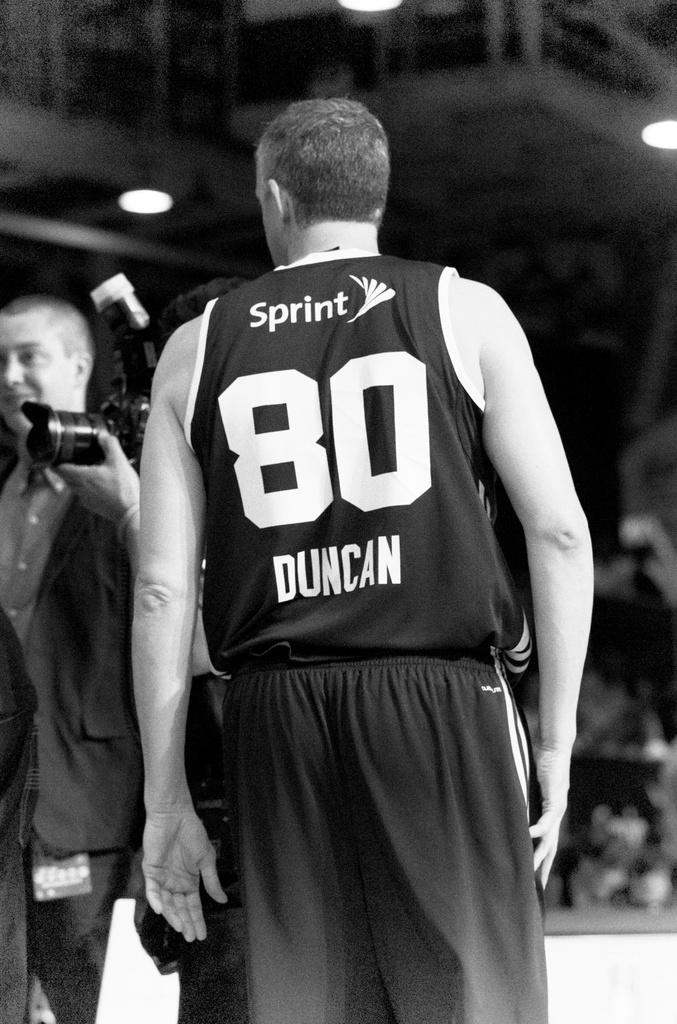<image>
Describe the image concisely. Duncan, who is player number 80, has the word Sprint on his shirt. 